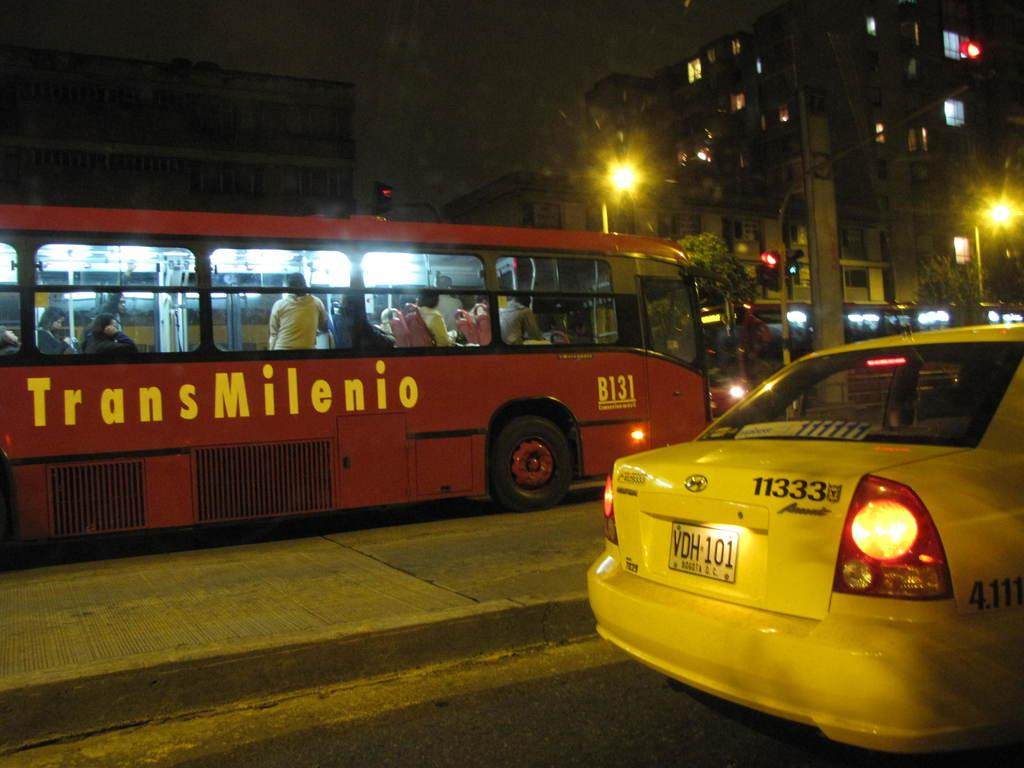Provide a one-sentence caption for the provided image. A red bus from the Trans Milenio line. 